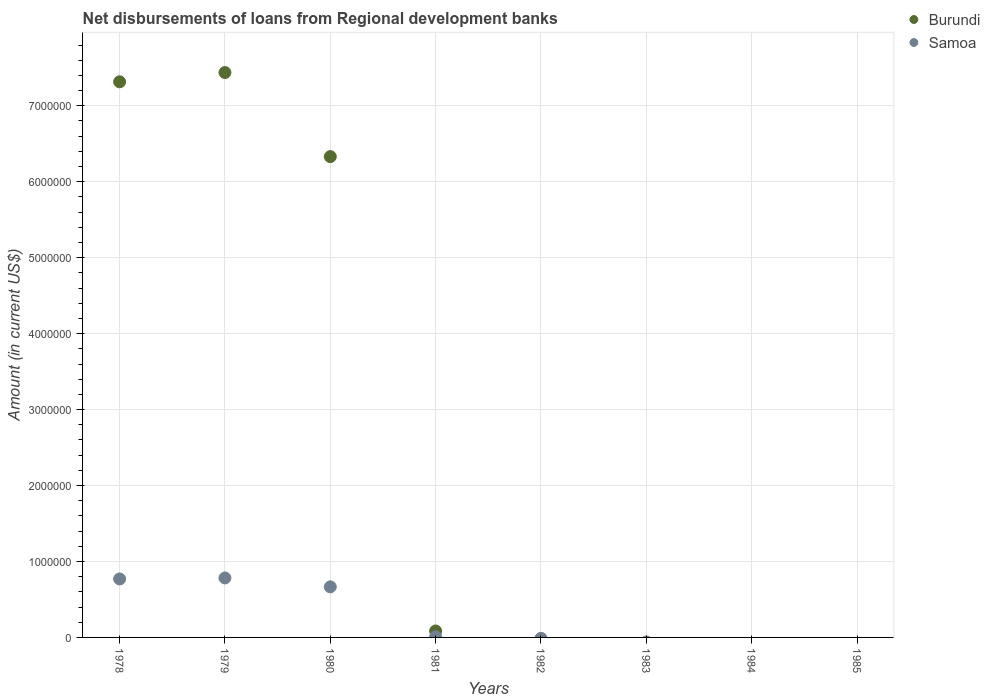How many different coloured dotlines are there?
Your answer should be very brief. 2. Across all years, what is the maximum amount of disbursements of loans from regional development banks in Samoa?
Give a very brief answer. 7.83e+05. In which year was the amount of disbursements of loans from regional development banks in Burundi maximum?
Give a very brief answer. 1979. What is the total amount of disbursements of loans from regional development banks in Burundi in the graph?
Your answer should be compact. 2.12e+07. What is the difference between the amount of disbursements of loans from regional development banks in Burundi in 1978 and that in 1981?
Provide a succinct answer. 7.23e+06. What is the difference between the amount of disbursements of loans from regional development banks in Burundi in 1985 and the amount of disbursements of loans from regional development banks in Samoa in 1980?
Give a very brief answer. -6.66e+05. What is the average amount of disbursements of loans from regional development banks in Burundi per year?
Your answer should be compact. 2.65e+06. In the year 1979, what is the difference between the amount of disbursements of loans from regional development banks in Burundi and amount of disbursements of loans from regional development banks in Samoa?
Your answer should be very brief. 6.66e+06. What is the difference between the highest and the second highest amount of disbursements of loans from regional development banks in Samoa?
Your answer should be very brief. 1.30e+04. What is the difference between the highest and the lowest amount of disbursements of loans from regional development banks in Samoa?
Ensure brevity in your answer.  7.83e+05. In how many years, is the amount of disbursements of loans from regional development banks in Burundi greater than the average amount of disbursements of loans from regional development banks in Burundi taken over all years?
Ensure brevity in your answer.  3. Is the sum of the amount of disbursements of loans from regional development banks in Burundi in 1978 and 1980 greater than the maximum amount of disbursements of loans from regional development banks in Samoa across all years?
Provide a short and direct response. Yes. Does the amount of disbursements of loans from regional development banks in Samoa monotonically increase over the years?
Provide a short and direct response. No. Is the amount of disbursements of loans from regional development banks in Burundi strictly greater than the amount of disbursements of loans from regional development banks in Samoa over the years?
Ensure brevity in your answer.  No. How many dotlines are there?
Your response must be concise. 2. What is the difference between two consecutive major ticks on the Y-axis?
Provide a succinct answer. 1.00e+06. Does the graph contain any zero values?
Offer a terse response. Yes. Where does the legend appear in the graph?
Offer a terse response. Top right. How are the legend labels stacked?
Keep it short and to the point. Vertical. What is the title of the graph?
Keep it short and to the point. Net disbursements of loans from Regional development banks. What is the label or title of the X-axis?
Ensure brevity in your answer.  Years. What is the Amount (in current US$) in Burundi in 1978?
Keep it short and to the point. 7.32e+06. What is the Amount (in current US$) of Samoa in 1978?
Your response must be concise. 7.70e+05. What is the Amount (in current US$) in Burundi in 1979?
Keep it short and to the point. 7.44e+06. What is the Amount (in current US$) in Samoa in 1979?
Offer a very short reply. 7.83e+05. What is the Amount (in current US$) of Burundi in 1980?
Your answer should be compact. 6.33e+06. What is the Amount (in current US$) of Samoa in 1980?
Provide a succinct answer. 6.66e+05. What is the Amount (in current US$) of Burundi in 1981?
Make the answer very short. 8.50e+04. What is the Amount (in current US$) of Samoa in 1981?
Provide a succinct answer. 9000. What is the Amount (in current US$) in Burundi in 1983?
Provide a short and direct response. 0. What is the Amount (in current US$) of Samoa in 1983?
Make the answer very short. 0. What is the Amount (in current US$) of Burundi in 1985?
Provide a short and direct response. 0. Across all years, what is the maximum Amount (in current US$) in Burundi?
Provide a short and direct response. 7.44e+06. Across all years, what is the maximum Amount (in current US$) in Samoa?
Your response must be concise. 7.83e+05. Across all years, what is the minimum Amount (in current US$) of Burundi?
Provide a succinct answer. 0. What is the total Amount (in current US$) in Burundi in the graph?
Keep it short and to the point. 2.12e+07. What is the total Amount (in current US$) in Samoa in the graph?
Make the answer very short. 2.23e+06. What is the difference between the Amount (in current US$) in Burundi in 1978 and that in 1979?
Your answer should be very brief. -1.22e+05. What is the difference between the Amount (in current US$) in Samoa in 1978 and that in 1979?
Keep it short and to the point. -1.30e+04. What is the difference between the Amount (in current US$) in Burundi in 1978 and that in 1980?
Make the answer very short. 9.85e+05. What is the difference between the Amount (in current US$) in Samoa in 1978 and that in 1980?
Your response must be concise. 1.04e+05. What is the difference between the Amount (in current US$) of Burundi in 1978 and that in 1981?
Make the answer very short. 7.23e+06. What is the difference between the Amount (in current US$) of Samoa in 1978 and that in 1981?
Provide a short and direct response. 7.61e+05. What is the difference between the Amount (in current US$) in Burundi in 1979 and that in 1980?
Offer a terse response. 1.11e+06. What is the difference between the Amount (in current US$) in Samoa in 1979 and that in 1980?
Make the answer very short. 1.17e+05. What is the difference between the Amount (in current US$) of Burundi in 1979 and that in 1981?
Offer a very short reply. 7.35e+06. What is the difference between the Amount (in current US$) in Samoa in 1979 and that in 1981?
Make the answer very short. 7.74e+05. What is the difference between the Amount (in current US$) of Burundi in 1980 and that in 1981?
Your answer should be compact. 6.25e+06. What is the difference between the Amount (in current US$) in Samoa in 1980 and that in 1981?
Your answer should be compact. 6.57e+05. What is the difference between the Amount (in current US$) in Burundi in 1978 and the Amount (in current US$) in Samoa in 1979?
Make the answer very short. 6.53e+06. What is the difference between the Amount (in current US$) in Burundi in 1978 and the Amount (in current US$) in Samoa in 1980?
Provide a short and direct response. 6.65e+06. What is the difference between the Amount (in current US$) of Burundi in 1978 and the Amount (in current US$) of Samoa in 1981?
Your answer should be compact. 7.31e+06. What is the difference between the Amount (in current US$) in Burundi in 1979 and the Amount (in current US$) in Samoa in 1980?
Keep it short and to the point. 6.77e+06. What is the difference between the Amount (in current US$) in Burundi in 1979 and the Amount (in current US$) in Samoa in 1981?
Provide a succinct answer. 7.43e+06. What is the difference between the Amount (in current US$) in Burundi in 1980 and the Amount (in current US$) in Samoa in 1981?
Ensure brevity in your answer.  6.32e+06. What is the average Amount (in current US$) of Burundi per year?
Your response must be concise. 2.65e+06. What is the average Amount (in current US$) in Samoa per year?
Offer a terse response. 2.78e+05. In the year 1978, what is the difference between the Amount (in current US$) of Burundi and Amount (in current US$) of Samoa?
Offer a very short reply. 6.55e+06. In the year 1979, what is the difference between the Amount (in current US$) in Burundi and Amount (in current US$) in Samoa?
Provide a short and direct response. 6.66e+06. In the year 1980, what is the difference between the Amount (in current US$) of Burundi and Amount (in current US$) of Samoa?
Provide a short and direct response. 5.66e+06. In the year 1981, what is the difference between the Amount (in current US$) in Burundi and Amount (in current US$) in Samoa?
Provide a short and direct response. 7.60e+04. What is the ratio of the Amount (in current US$) in Burundi in 1978 to that in 1979?
Your answer should be very brief. 0.98. What is the ratio of the Amount (in current US$) in Samoa in 1978 to that in 1979?
Your answer should be very brief. 0.98. What is the ratio of the Amount (in current US$) of Burundi in 1978 to that in 1980?
Your response must be concise. 1.16. What is the ratio of the Amount (in current US$) of Samoa in 1978 to that in 1980?
Offer a very short reply. 1.16. What is the ratio of the Amount (in current US$) in Burundi in 1978 to that in 1981?
Provide a succinct answer. 86.07. What is the ratio of the Amount (in current US$) of Samoa in 1978 to that in 1981?
Your answer should be compact. 85.56. What is the ratio of the Amount (in current US$) of Burundi in 1979 to that in 1980?
Offer a terse response. 1.17. What is the ratio of the Amount (in current US$) in Samoa in 1979 to that in 1980?
Your answer should be very brief. 1.18. What is the ratio of the Amount (in current US$) in Burundi in 1979 to that in 1981?
Offer a very short reply. 87.51. What is the ratio of the Amount (in current US$) in Burundi in 1980 to that in 1981?
Provide a short and direct response. 74.48. What is the difference between the highest and the second highest Amount (in current US$) in Burundi?
Provide a short and direct response. 1.22e+05. What is the difference between the highest and the second highest Amount (in current US$) in Samoa?
Make the answer very short. 1.30e+04. What is the difference between the highest and the lowest Amount (in current US$) of Burundi?
Offer a very short reply. 7.44e+06. What is the difference between the highest and the lowest Amount (in current US$) of Samoa?
Your answer should be very brief. 7.83e+05. 